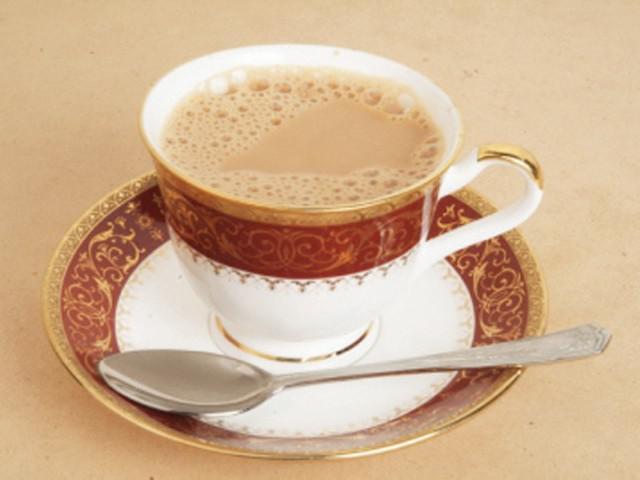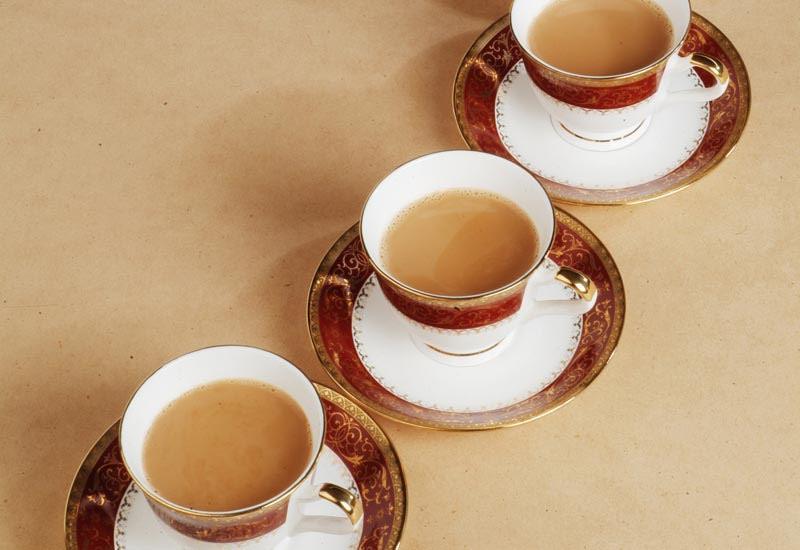The first image is the image on the left, the second image is the image on the right. Examine the images to the left and right. Is the description "Cups in the right image are on saucers, and cups in the left image are not." accurate? Answer yes or no. No. The first image is the image on the left, the second image is the image on the right. Examine the images to the left and right. Is the description "There is at least one spoon placed in a saucer." accurate? Answer yes or no. Yes. 